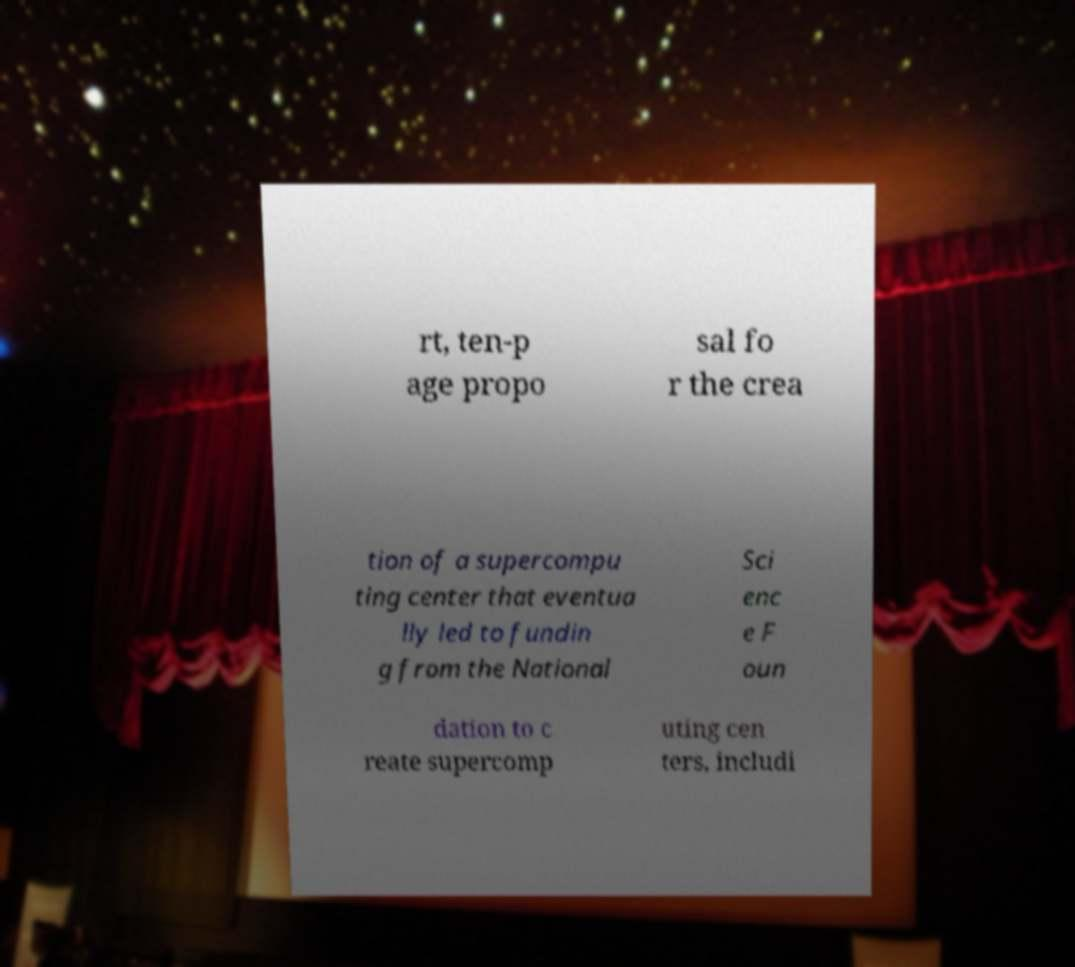Could you extract and type out the text from this image? rt, ten-p age propo sal fo r the crea tion of a supercompu ting center that eventua lly led to fundin g from the National Sci enc e F oun dation to c reate supercomp uting cen ters, includi 